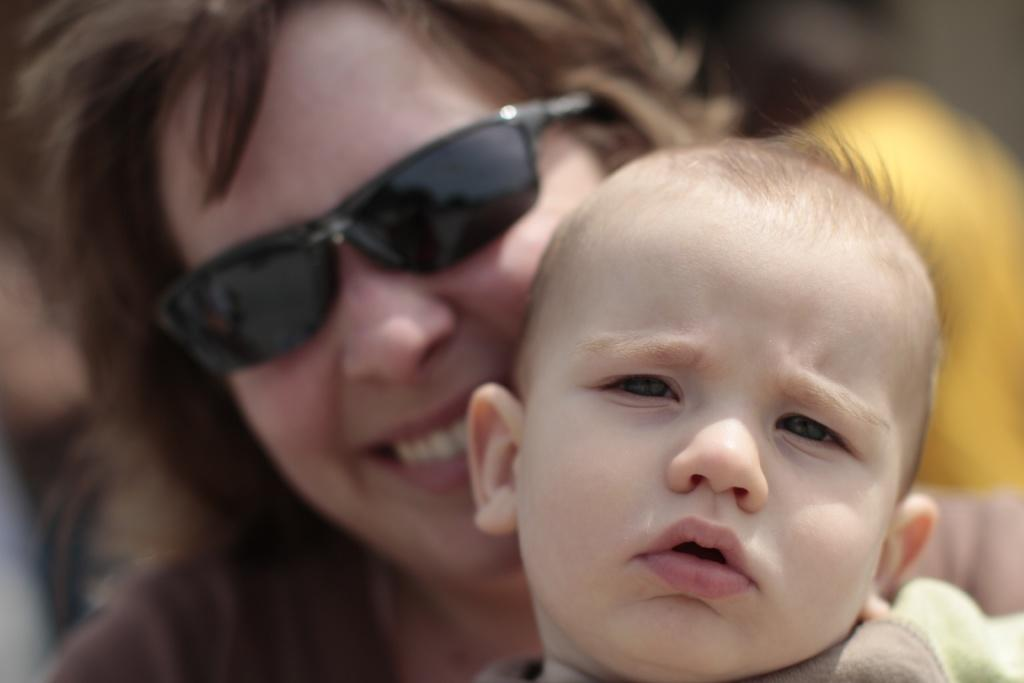Who is present in the image? There is a woman and a baby in the image. What is the woman doing in the image? The woman is smiling in the image. What is the woman wearing that is noticeable? The woman is wearing black color spectacles. What is the baby doing in the image? The baby is looking at the side in the image. What is the baby wearing that is noticeable? The baby is wearing brown and green color cloth. What type of jeans is the air wearing in the image? There is no air present in the image, and therefore no one is wearing jeans. 